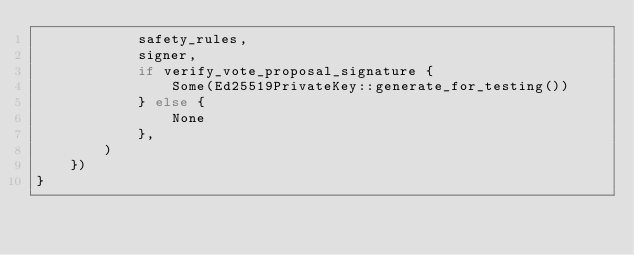<code> <loc_0><loc_0><loc_500><loc_500><_Rust_>            safety_rules,
            signer,
            if verify_vote_proposal_signature {
                Some(Ed25519PrivateKey::generate_for_testing())
            } else {
                None
            },
        )
    })
}
</code> 